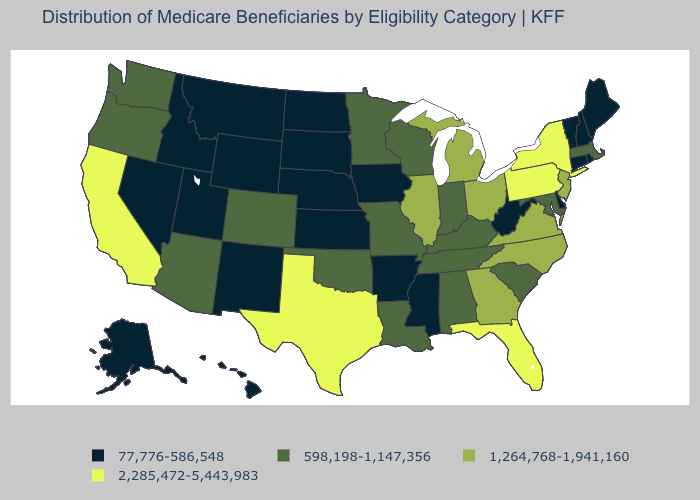What is the value of Indiana?
Concise answer only. 598,198-1,147,356. Which states have the highest value in the USA?
Answer briefly. California, Florida, New York, Pennsylvania, Texas. Does the map have missing data?
Quick response, please. No. What is the value of Hawaii?
Write a very short answer. 77,776-586,548. Which states have the highest value in the USA?
Give a very brief answer. California, Florida, New York, Pennsylvania, Texas. Name the states that have a value in the range 598,198-1,147,356?
Give a very brief answer. Alabama, Arizona, Colorado, Indiana, Kentucky, Louisiana, Maryland, Massachusetts, Minnesota, Missouri, Oklahoma, Oregon, South Carolina, Tennessee, Washington, Wisconsin. What is the value of Utah?
Concise answer only. 77,776-586,548. Does North Carolina have the highest value in the USA?
Give a very brief answer. No. Among the states that border Oklahoma , does Texas have the lowest value?
Keep it brief. No. What is the value of Indiana?
Give a very brief answer. 598,198-1,147,356. Does Tennessee have the highest value in the USA?
Be succinct. No. Among the states that border Illinois , which have the lowest value?
Write a very short answer. Iowa. Name the states that have a value in the range 598,198-1,147,356?
Write a very short answer. Alabama, Arizona, Colorado, Indiana, Kentucky, Louisiana, Maryland, Massachusetts, Minnesota, Missouri, Oklahoma, Oregon, South Carolina, Tennessee, Washington, Wisconsin. What is the value of Mississippi?
Write a very short answer. 77,776-586,548. Name the states that have a value in the range 598,198-1,147,356?
Write a very short answer. Alabama, Arizona, Colorado, Indiana, Kentucky, Louisiana, Maryland, Massachusetts, Minnesota, Missouri, Oklahoma, Oregon, South Carolina, Tennessee, Washington, Wisconsin. 